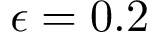<formula> <loc_0><loc_0><loc_500><loc_500>\epsilon = 0 . 2</formula> 